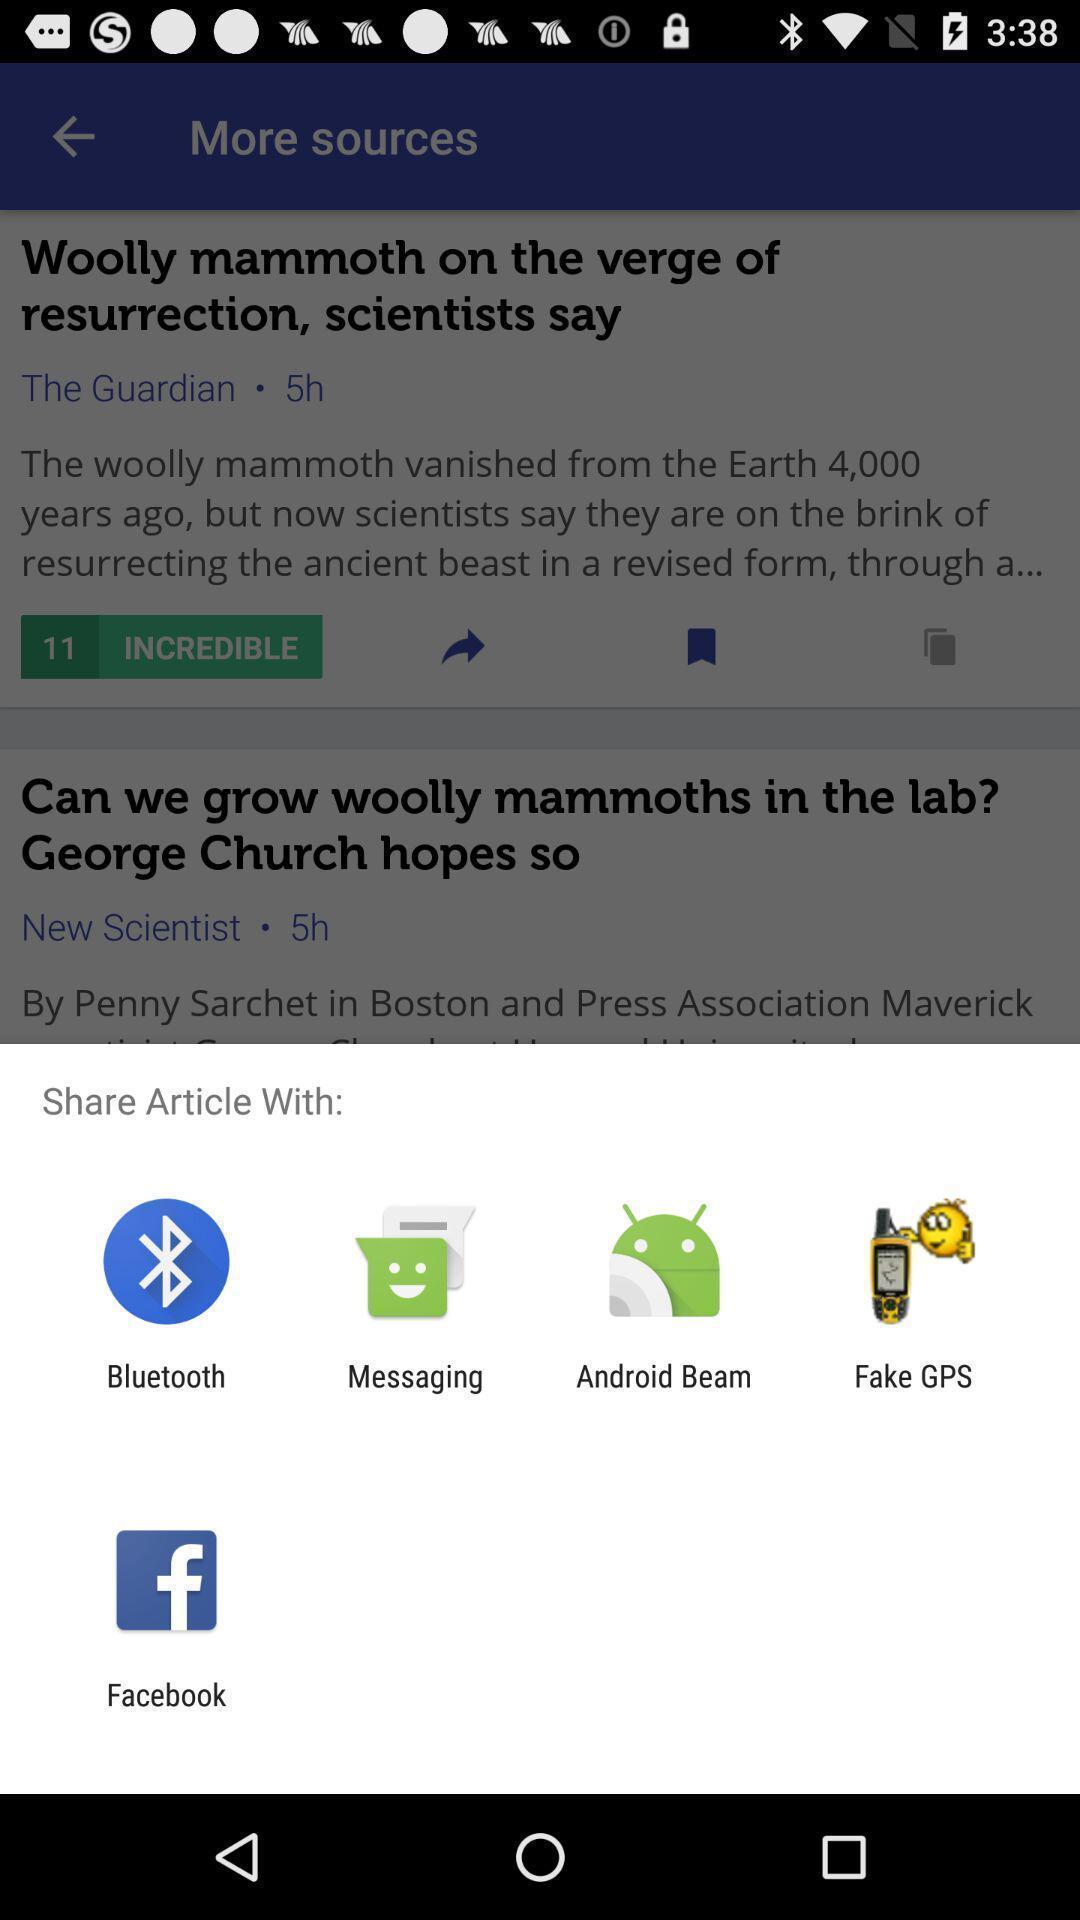Please provide a description for this image. Popup to share an article for the science study app. 